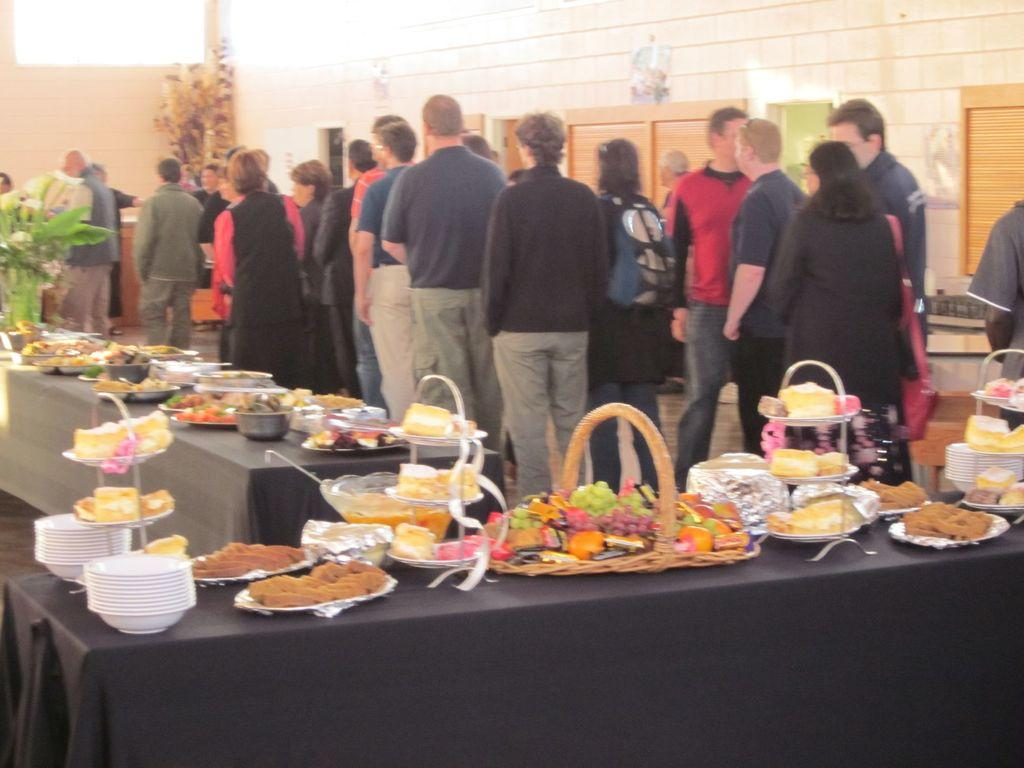What can be seen in the image in terms of human presence? There are people standing in the image. What type of furniture is visible in the image? There are tables in the image. What is placed on the tables? Food items, plates, spoons, and bowls are present on the tables. What hobbies do the people in the image have in common? There is no information about the hobbies of the people in the image, so we cannot determine any common hobbies. 